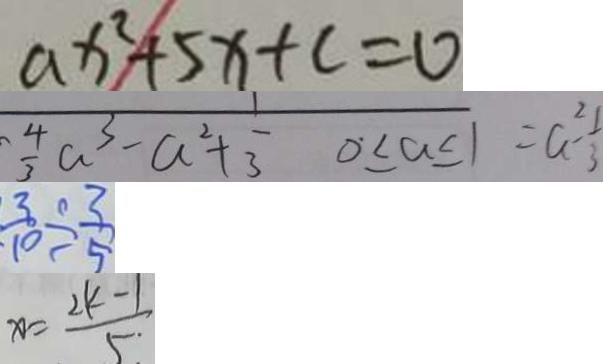<formula> <loc_0><loc_0><loc_500><loc_500>a x ^ { 2 } + 5 x + c = 0 
 \frac { 4 } { 3 } a ^ { 3 } - a ^ { 2 } + \frac { 1 } { 3 } 0 \leq a \leq 1 = a ^ { 2 } - \frac { 1 } { 3 } 
 \frac { 3 } { 1 0 } \div \frac { 3 } { 5 } 
 x = \frac { 2 k - 1 } { 5 }</formula> 